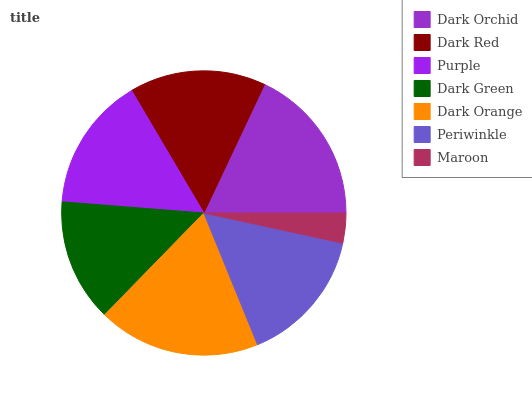Is Maroon the minimum?
Answer yes or no. Yes. Is Dark Orange the maximum?
Answer yes or no. Yes. Is Dark Red the minimum?
Answer yes or no. No. Is Dark Red the maximum?
Answer yes or no. No. Is Dark Orchid greater than Dark Red?
Answer yes or no. Yes. Is Dark Red less than Dark Orchid?
Answer yes or no. Yes. Is Dark Red greater than Dark Orchid?
Answer yes or no. No. Is Dark Orchid less than Dark Red?
Answer yes or no. No. Is Periwinkle the high median?
Answer yes or no. Yes. Is Periwinkle the low median?
Answer yes or no. Yes. Is Dark Green the high median?
Answer yes or no. No. Is Dark Red the low median?
Answer yes or no. No. 